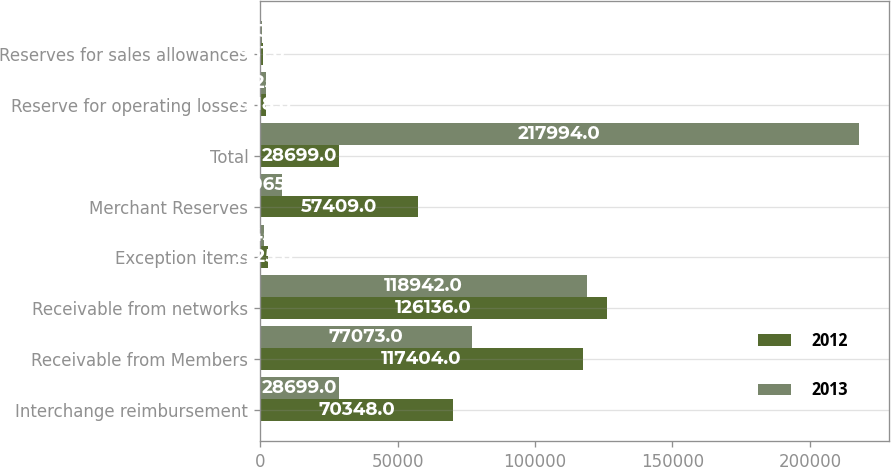Convert chart. <chart><loc_0><loc_0><loc_500><loc_500><stacked_bar_chart><ecel><fcel>Interchange reimbursement<fcel>Receivable from Members<fcel>Receivable from networks<fcel>Exception items<fcel>Merchant Reserves<fcel>Total<fcel>Reserve for operating losses<fcel>Reserves for sales allowances<nl><fcel>2012<fcel>70348<fcel>117404<fcel>126136<fcel>2725<fcel>57409<fcel>28699<fcel>2318<fcel>961<nl><fcel>2013<fcel>28699<fcel>77073<fcel>118942<fcel>1345<fcel>8065<fcel>217994<fcel>2325<fcel>873<nl></chart> 